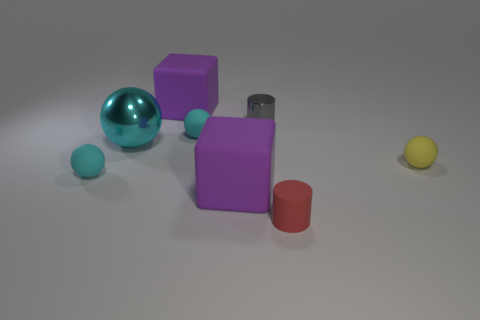Subtract all red cylinders. How many cyan balls are left? 3 Subtract all blue balls. Subtract all yellow cylinders. How many balls are left? 4 Add 1 matte cylinders. How many objects exist? 9 Subtract all cubes. How many objects are left? 6 Subtract 0 cyan blocks. How many objects are left? 8 Subtract all gray cylinders. Subtract all cyan rubber balls. How many objects are left? 5 Add 4 tiny cyan matte things. How many tiny cyan matte things are left? 6 Add 4 tiny matte balls. How many tiny matte balls exist? 7 